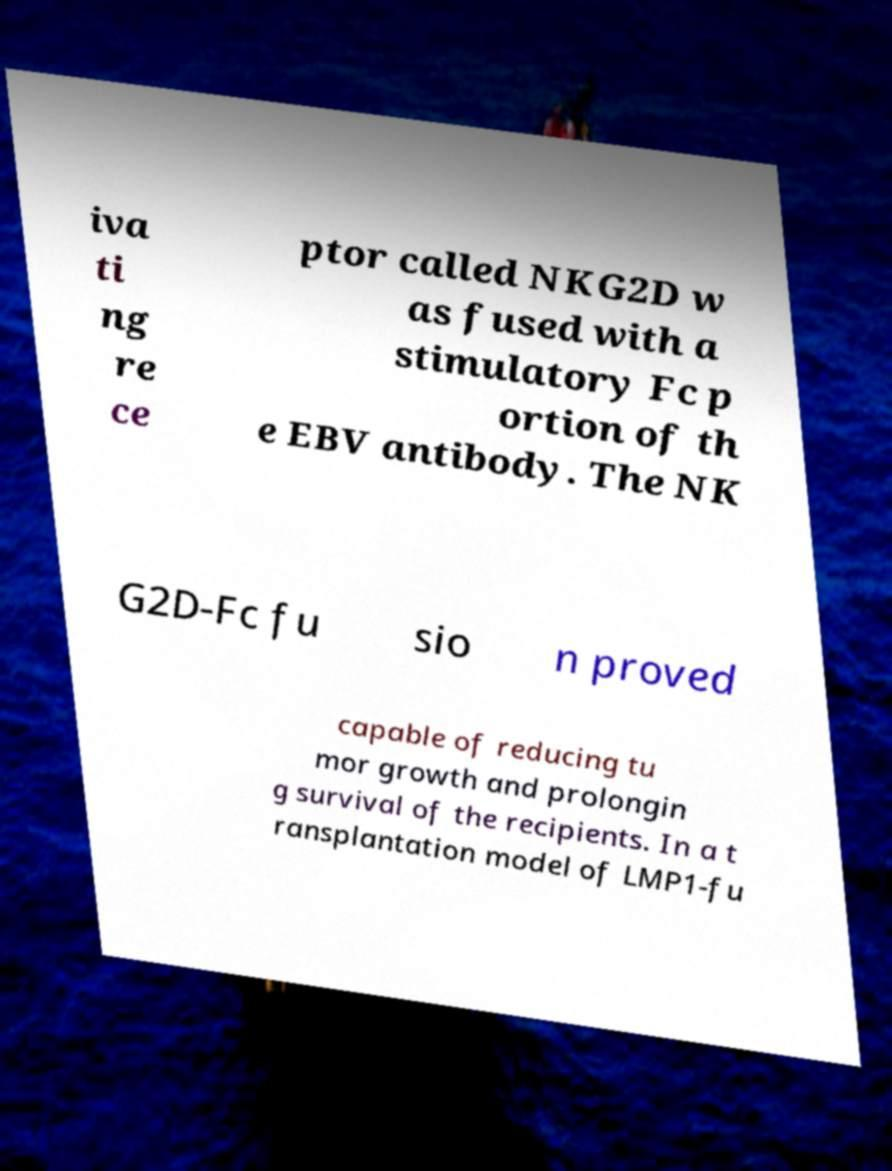Could you extract and type out the text from this image? iva ti ng re ce ptor called NKG2D w as fused with a stimulatory Fc p ortion of th e EBV antibody. The NK G2D-Fc fu sio n proved capable of reducing tu mor growth and prolongin g survival of the recipients. In a t ransplantation model of LMP1-fu 